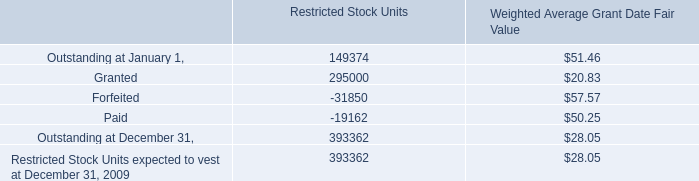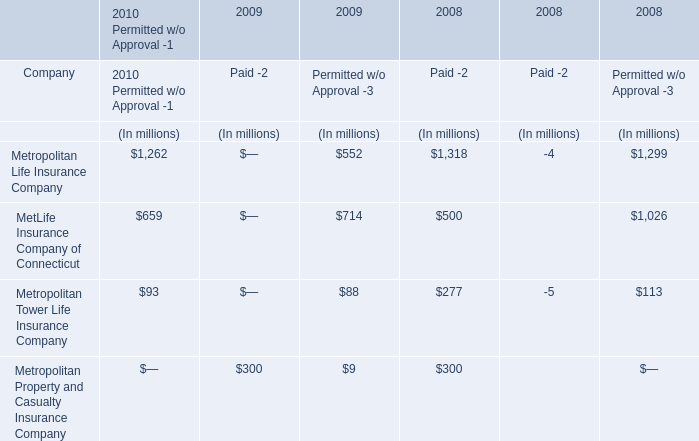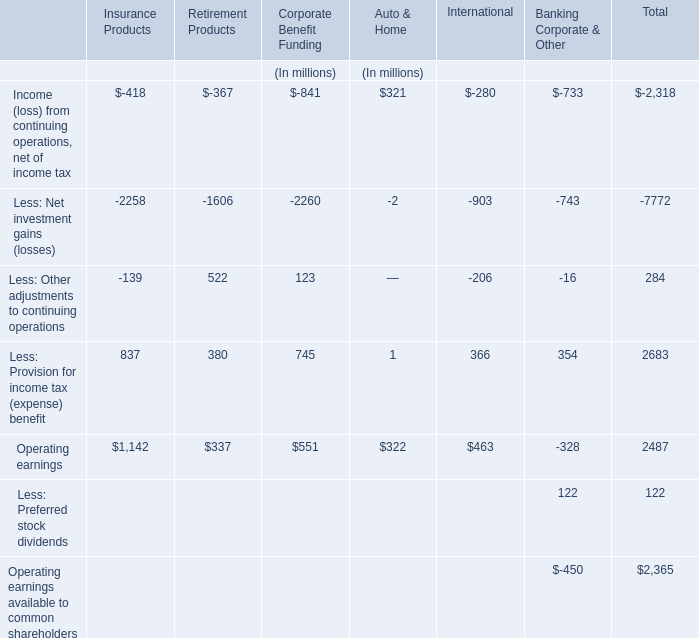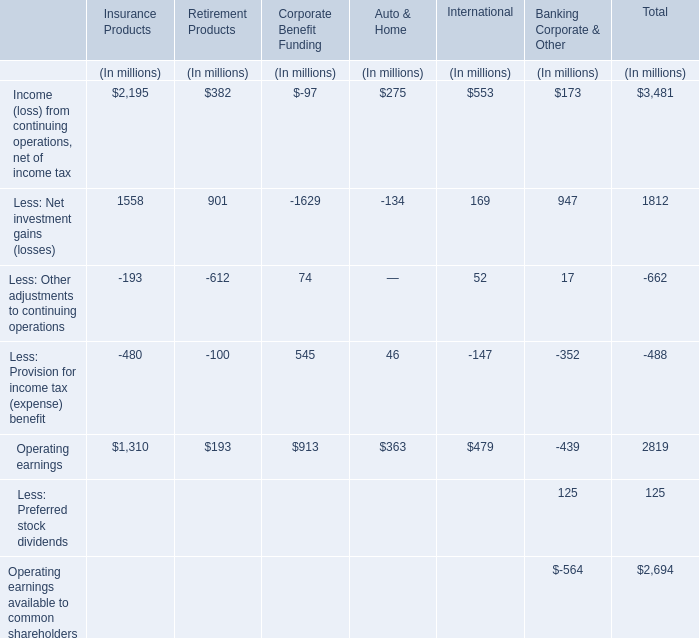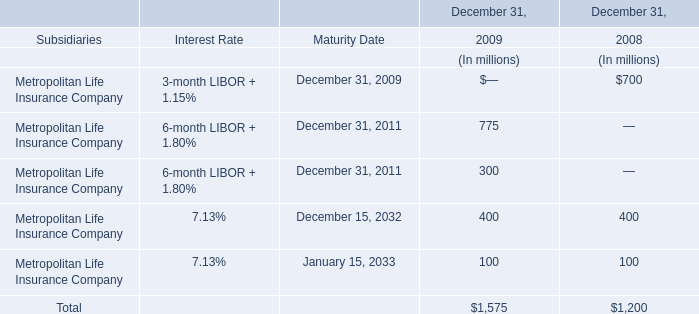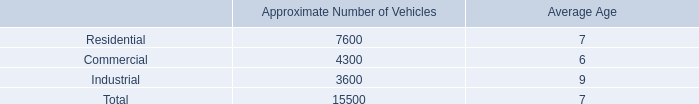What was the sum of Corporate Benefit Funding without those Corporate Benefit Funding smaller than100? (in million) 
Computations: (545 + 913)
Answer: 1458.0. 